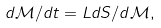Convert formula to latex. <formula><loc_0><loc_0><loc_500><loc_500>d \mathcal { M } / d t = L d S / d \mathcal { M } ,</formula> 